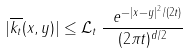Convert formula to latex. <formula><loc_0><loc_0><loc_500><loc_500>| \overline { k _ { t } } ( x , y ) | \leq \mathcal { L } _ { t } \, \frac { \ e ^ { - | x - y | ^ { 2 } / ( 2 t ) } } { ( 2 \pi t ) ^ { d / 2 } }</formula> 